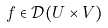Convert formula to latex. <formula><loc_0><loc_0><loc_500><loc_500>f \in { \mathcal { D } } ( U \times V )</formula> 